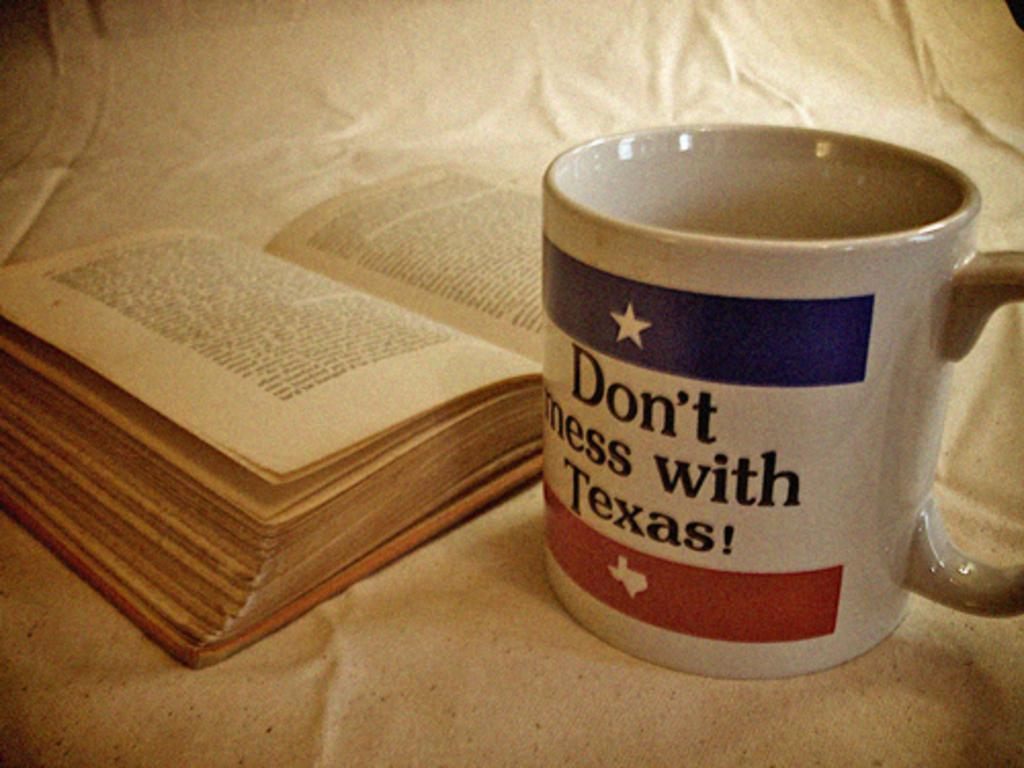<image>
Relay a brief, clear account of the picture shown. An open book is next to a coffee cup that says "don't mess with Texas!". 